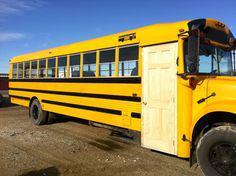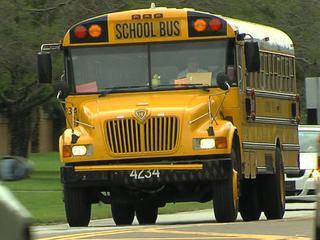The first image is the image on the left, the second image is the image on the right. Given the left and right images, does the statement "One of the buses is built with a house door." hold true? Answer yes or no. Yes. 